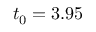Convert formula to latex. <formula><loc_0><loc_0><loc_500><loc_500>t _ { 0 } = 3 . 9 5</formula> 